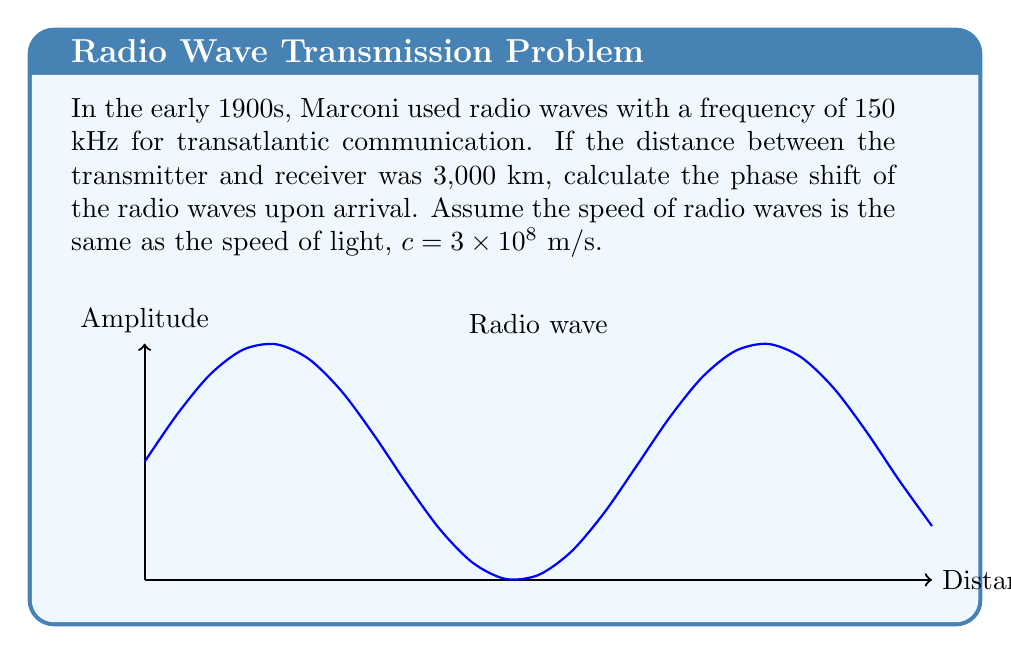What is the answer to this math problem? Let's approach this step-by-step:

1) The phase shift $\phi$ is given by the formula:

   $$\phi = \frac{2\pi d}{\lambda}$$

   where $d$ is the distance traveled and $\lambda$ is the wavelength.

2) We need to find the wavelength $\lambda$. We can use the relation:

   $$c = f\lambda$$

   where $c$ is the speed of light and $f$ is the frequency.

3) Rearranging for $\lambda$:

   $$\lambda = \frac{c}{f} = \frac{3 \times 10^8}{150 \times 10^3} = 2000 \text{ m}$$

4) Now we can substitute into our phase shift formula:

   $$\phi = \frac{2\pi d}{\lambda} = \frac{2\pi (3,000,000)}{2000}$$

5) Simplifying:

   $$\phi = 3000\pi \text{ radians}$$

6) To convert to a fraction of a complete cycle (2π radians), we divide by 2π:

   $$\frac{\phi}{2\pi} = \frac{3000\pi}{2\pi} = 1500 \text{ cycles}$$

7) The fractional part of this number represents the phase shift as a fraction of a complete cycle:

   $$1500 - 1500 = 0$$

Therefore, the phase shift is 0 or a complete number of cycles.
Answer: 0 radians (or 0 cycles) 